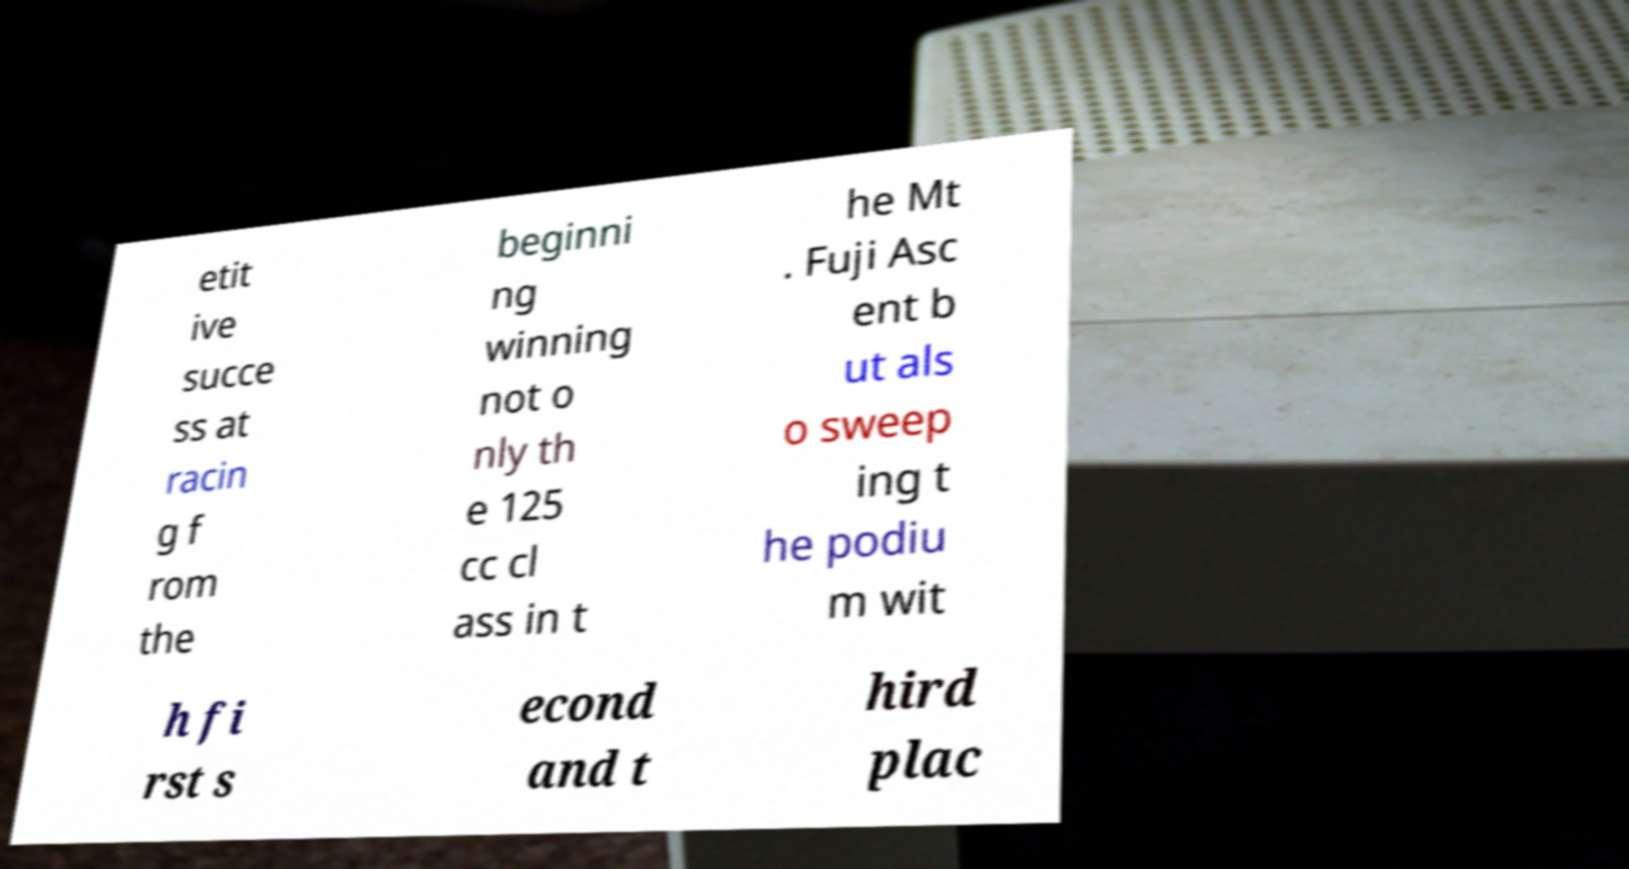I need the written content from this picture converted into text. Can you do that? etit ive succe ss at racin g f rom the beginni ng winning not o nly th e 125 cc cl ass in t he Mt . Fuji Asc ent b ut als o sweep ing t he podiu m wit h fi rst s econd and t hird plac 